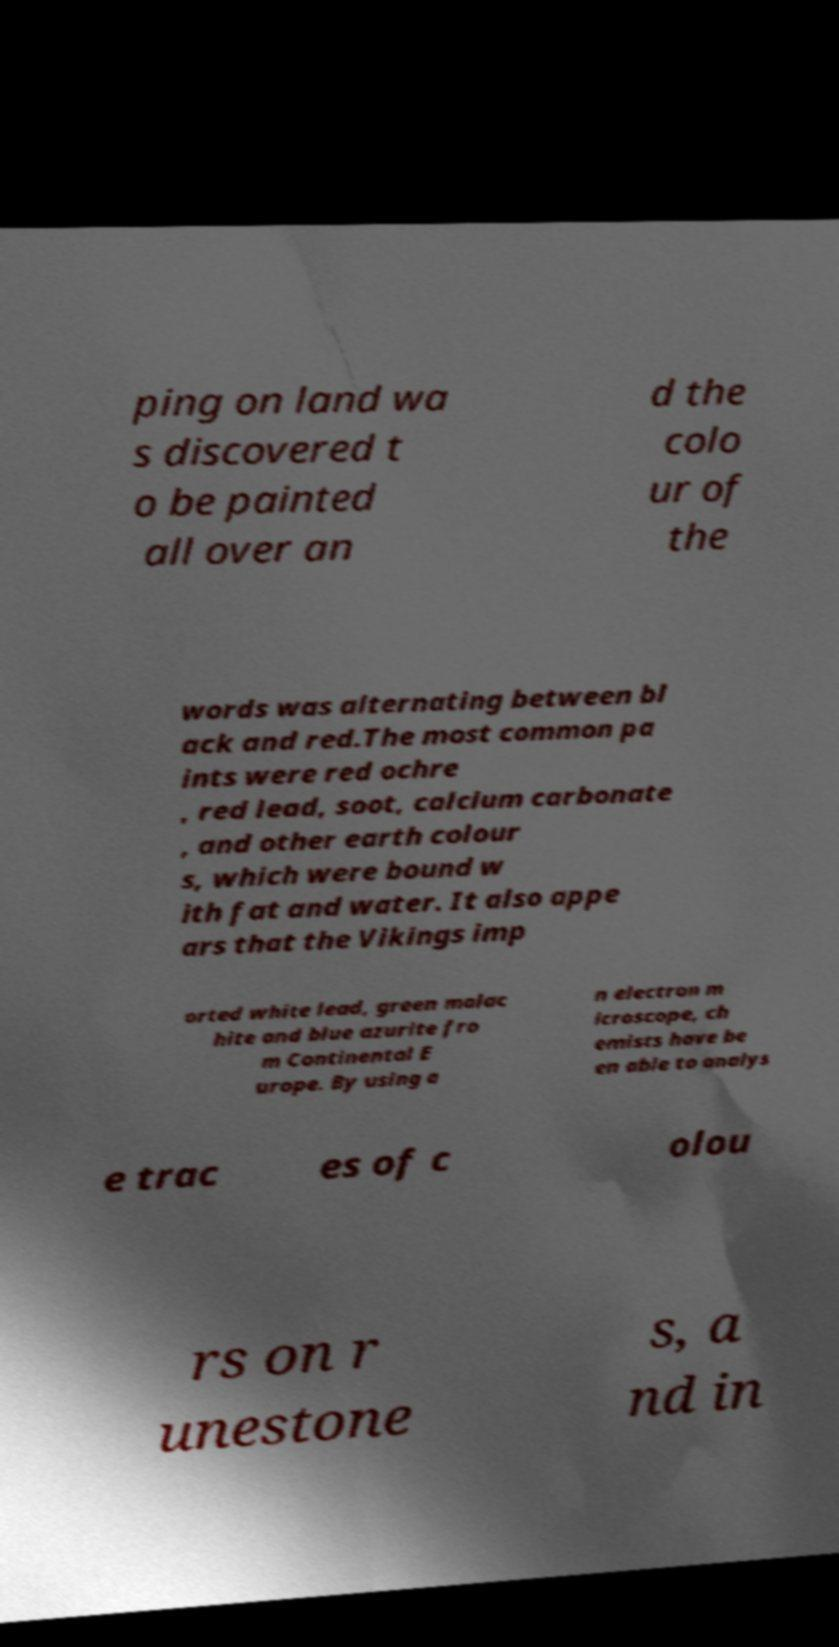I need the written content from this picture converted into text. Can you do that? ping on land wa s discovered t o be painted all over an d the colo ur of the words was alternating between bl ack and red.The most common pa ints were red ochre , red lead, soot, calcium carbonate , and other earth colour s, which were bound w ith fat and water. It also appe ars that the Vikings imp orted white lead, green malac hite and blue azurite fro m Continental E urope. By using a n electron m icroscope, ch emists have be en able to analys e trac es of c olou rs on r unestone s, a nd in 